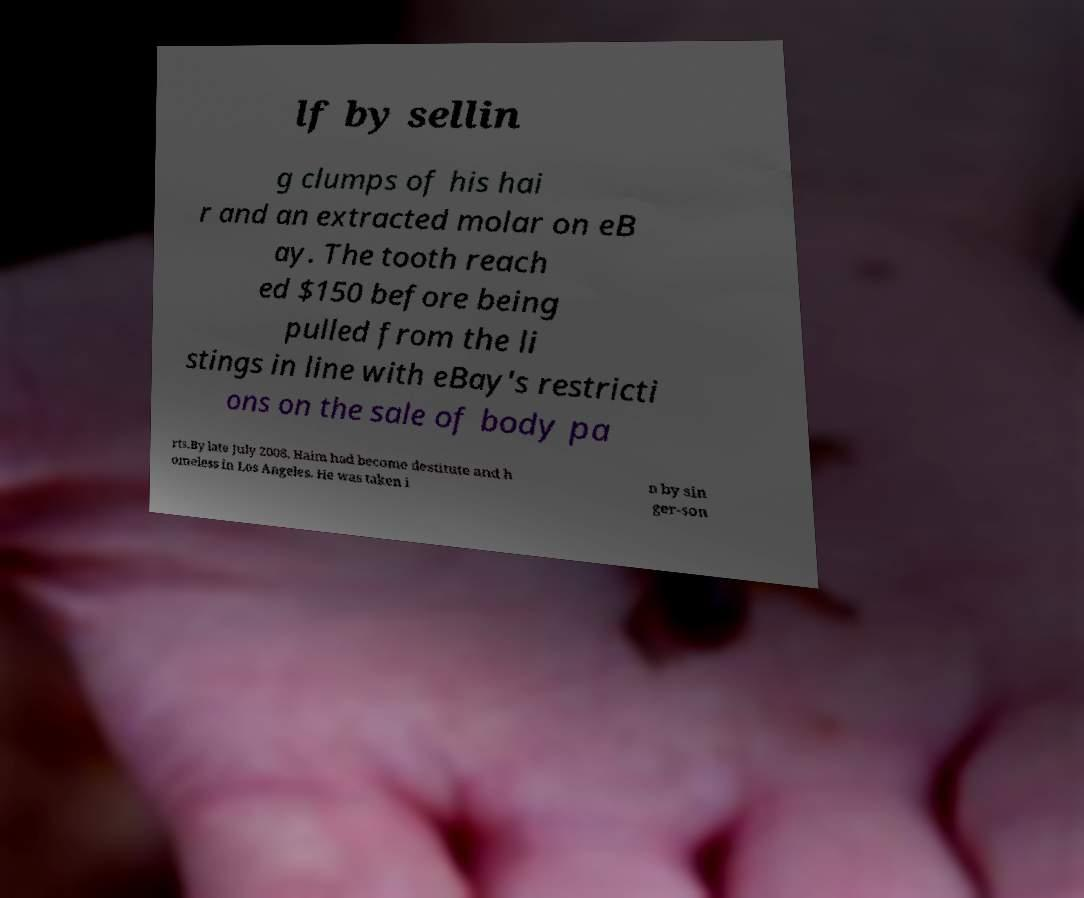I need the written content from this picture converted into text. Can you do that? lf by sellin g clumps of his hai r and an extracted molar on eB ay. The tooth reach ed $150 before being pulled from the li stings in line with eBay's restricti ons on the sale of body pa rts.By late July 2008, Haim had become destitute and h omeless in Los Angeles. He was taken i n by sin ger-son 